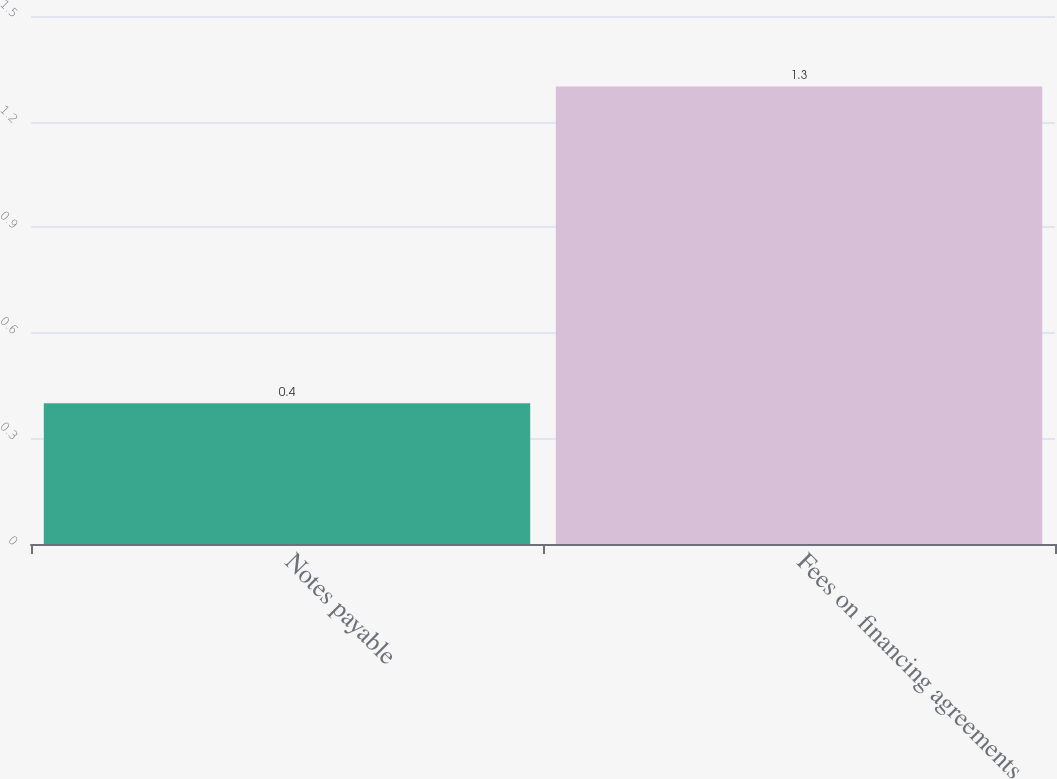Convert chart to OTSL. <chart><loc_0><loc_0><loc_500><loc_500><bar_chart><fcel>Notes payable<fcel>Fees on financing agreements<nl><fcel>0.4<fcel>1.3<nl></chart> 